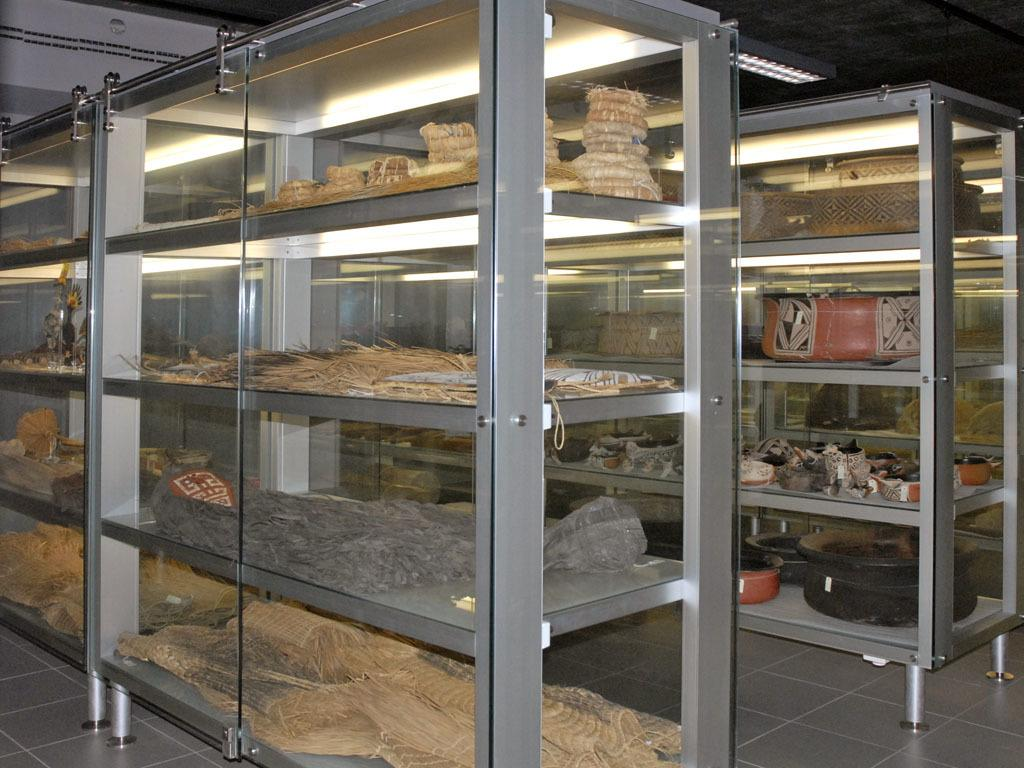What can be found on the shelves in the image? There are bowls, threads, and other objects on the shelves. How are the shelves protected or enclosed? The shelves are covered with glass. Where are the shelves located in the image? The shelves are on the floor. Is there any source of light visible in the image? Yes, there is a light attached to the roof in the background. What type of juice can be seen being poured from a coil in the image? There is no coil or juice present in the image. 